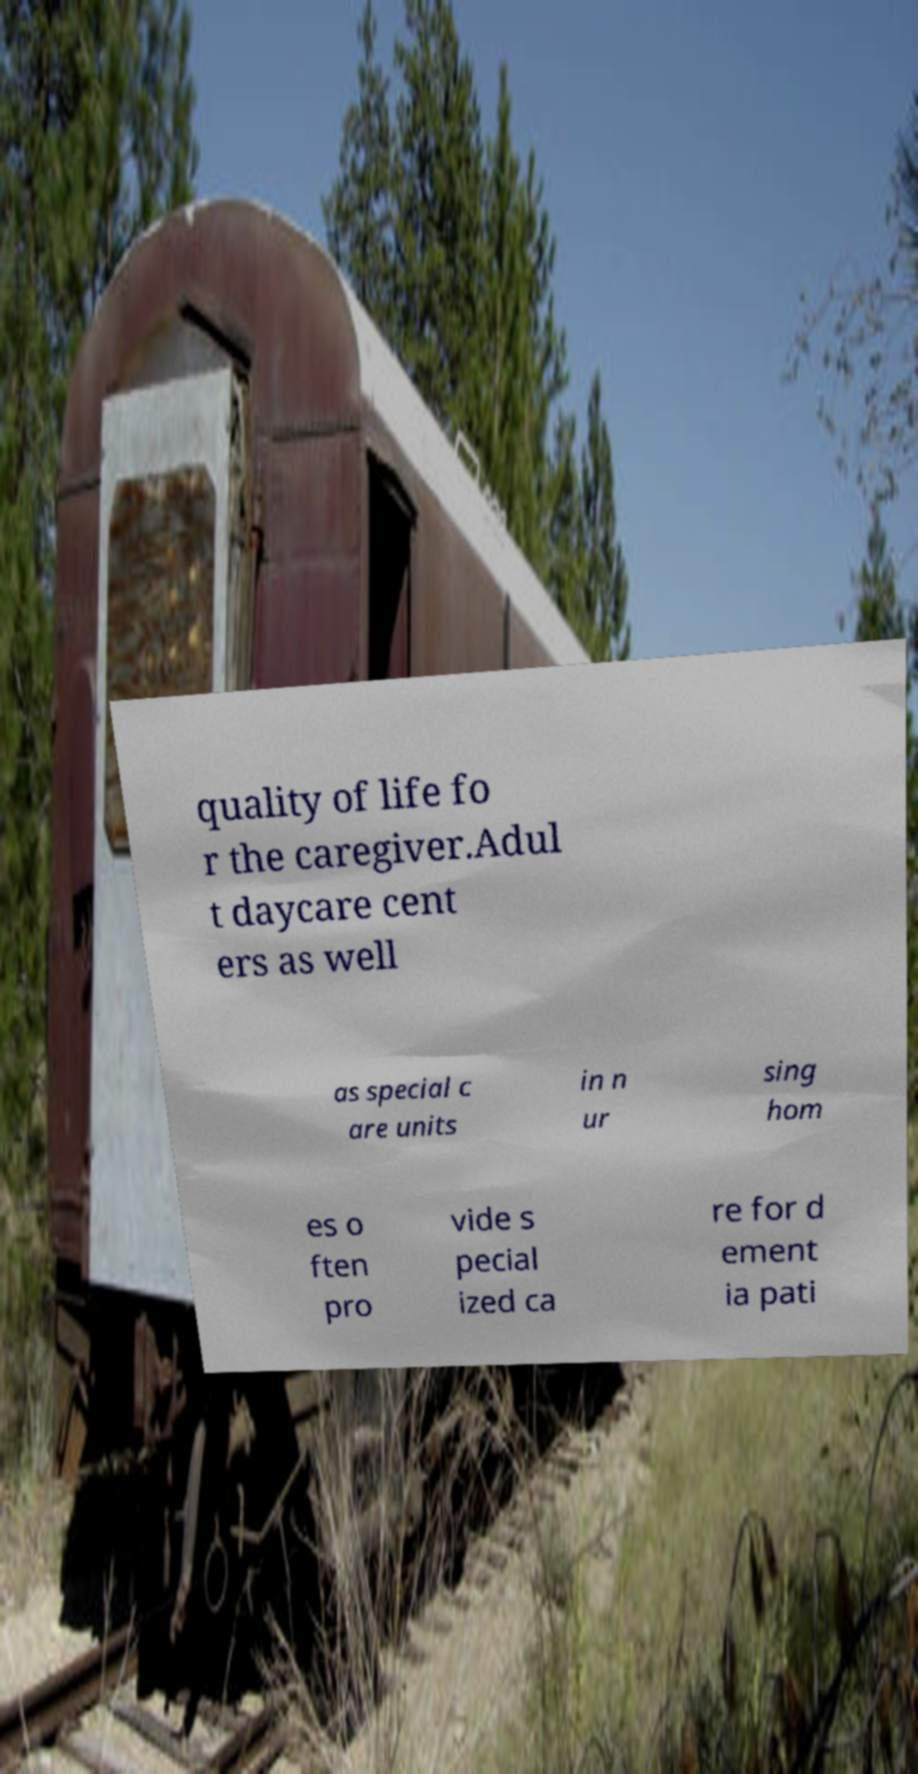Can you accurately transcribe the text from the provided image for me? quality of life fo r the caregiver.Adul t daycare cent ers as well as special c are units in n ur sing hom es o ften pro vide s pecial ized ca re for d ement ia pati 